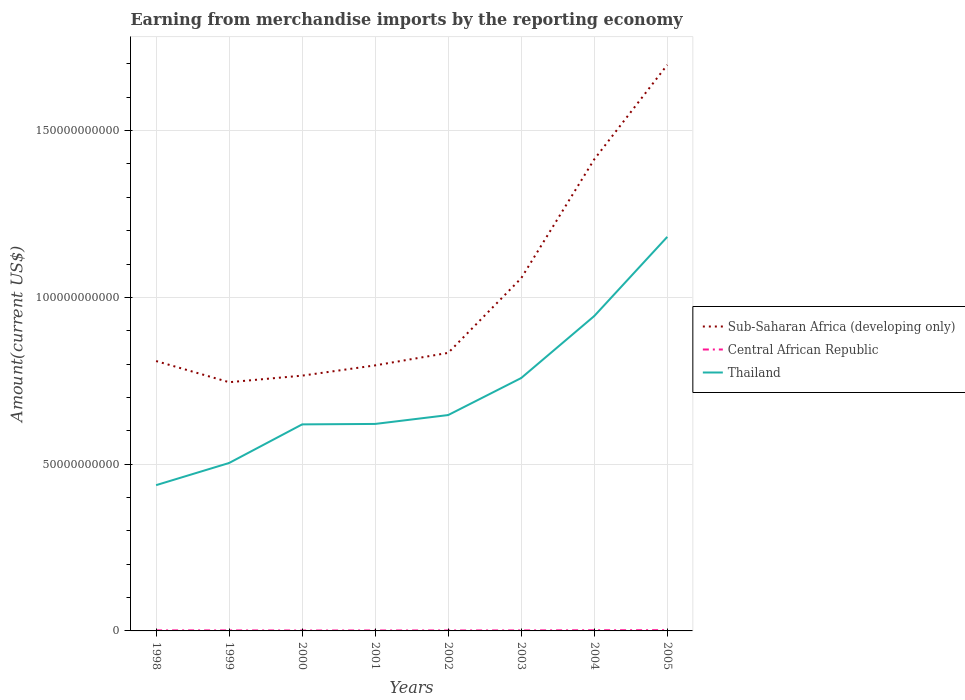How many different coloured lines are there?
Your answer should be very brief. 3. Does the line corresponding to Sub-Saharan Africa (developing only) intersect with the line corresponding to Central African Republic?
Provide a short and direct response. No. Is the number of lines equal to the number of legend labels?
Your answer should be very brief. Yes. Across all years, what is the maximum amount earned from merchandise imports in Sub-Saharan Africa (developing only)?
Your answer should be very brief. 7.46e+1. In which year was the amount earned from merchandise imports in Thailand maximum?
Your response must be concise. 1998. What is the total amount earned from merchandise imports in Central African Republic in the graph?
Make the answer very short. 7.74e+06. What is the difference between the highest and the second highest amount earned from merchandise imports in Thailand?
Your answer should be compact. 7.44e+1. What is the difference between the highest and the lowest amount earned from merchandise imports in Central African Republic?
Keep it short and to the point. 3. Is the amount earned from merchandise imports in Thailand strictly greater than the amount earned from merchandise imports in Central African Republic over the years?
Give a very brief answer. No. Where does the legend appear in the graph?
Give a very brief answer. Center right. How many legend labels are there?
Your response must be concise. 3. How are the legend labels stacked?
Offer a terse response. Vertical. What is the title of the graph?
Your response must be concise. Earning from merchandise imports by the reporting economy. Does "Zambia" appear as one of the legend labels in the graph?
Keep it short and to the point. No. What is the label or title of the X-axis?
Provide a short and direct response. Years. What is the label or title of the Y-axis?
Your answer should be very brief. Amount(current US$). What is the Amount(current US$) in Sub-Saharan Africa (developing only) in 1998?
Offer a terse response. 8.09e+1. What is the Amount(current US$) of Central African Republic in 1998?
Your answer should be very brief. 1.62e+08. What is the Amount(current US$) in Thailand in 1998?
Ensure brevity in your answer.  4.37e+1. What is the Amount(current US$) of Sub-Saharan Africa (developing only) in 1999?
Offer a terse response. 7.46e+1. What is the Amount(current US$) in Central African Republic in 1999?
Make the answer very short. 1.54e+08. What is the Amount(current US$) in Thailand in 1999?
Ensure brevity in your answer.  5.04e+1. What is the Amount(current US$) of Sub-Saharan Africa (developing only) in 2000?
Ensure brevity in your answer.  7.65e+1. What is the Amount(current US$) of Central African Republic in 2000?
Provide a short and direct response. 1.21e+08. What is the Amount(current US$) in Thailand in 2000?
Your answer should be very brief. 6.19e+1. What is the Amount(current US$) of Sub-Saharan Africa (developing only) in 2001?
Your answer should be compact. 7.96e+1. What is the Amount(current US$) in Central African Republic in 2001?
Provide a short and direct response. 1.34e+08. What is the Amount(current US$) in Thailand in 2001?
Offer a terse response. 6.21e+1. What is the Amount(current US$) in Sub-Saharan Africa (developing only) in 2002?
Make the answer very short. 8.34e+1. What is the Amount(current US$) in Central African Republic in 2002?
Offer a terse response. 1.41e+08. What is the Amount(current US$) in Thailand in 2002?
Provide a succinct answer. 6.47e+1. What is the Amount(current US$) of Sub-Saharan Africa (developing only) in 2003?
Offer a terse response. 1.06e+11. What is the Amount(current US$) of Central African Republic in 2003?
Offer a terse response. 1.48e+08. What is the Amount(current US$) in Thailand in 2003?
Ensure brevity in your answer.  7.58e+1. What is the Amount(current US$) in Sub-Saharan Africa (developing only) in 2004?
Provide a short and direct response. 1.41e+11. What is the Amount(current US$) in Central African Republic in 2004?
Give a very brief answer. 2.02e+08. What is the Amount(current US$) of Thailand in 2004?
Give a very brief answer. 9.44e+1. What is the Amount(current US$) in Sub-Saharan Africa (developing only) in 2005?
Your response must be concise. 1.70e+11. What is the Amount(current US$) of Central African Republic in 2005?
Keep it short and to the point. 2.25e+08. What is the Amount(current US$) in Thailand in 2005?
Your response must be concise. 1.18e+11. Across all years, what is the maximum Amount(current US$) of Sub-Saharan Africa (developing only)?
Make the answer very short. 1.70e+11. Across all years, what is the maximum Amount(current US$) in Central African Republic?
Provide a succinct answer. 2.25e+08. Across all years, what is the maximum Amount(current US$) of Thailand?
Offer a very short reply. 1.18e+11. Across all years, what is the minimum Amount(current US$) in Sub-Saharan Africa (developing only)?
Provide a succinct answer. 7.46e+1. Across all years, what is the minimum Amount(current US$) in Central African Republic?
Your answer should be compact. 1.21e+08. Across all years, what is the minimum Amount(current US$) of Thailand?
Give a very brief answer. 4.37e+1. What is the total Amount(current US$) in Sub-Saharan Africa (developing only) in the graph?
Offer a very short reply. 8.12e+11. What is the total Amount(current US$) in Central African Republic in the graph?
Your response must be concise. 1.29e+09. What is the total Amount(current US$) in Thailand in the graph?
Offer a terse response. 5.71e+11. What is the difference between the Amount(current US$) in Sub-Saharan Africa (developing only) in 1998 and that in 1999?
Give a very brief answer. 6.34e+09. What is the difference between the Amount(current US$) of Central African Republic in 1998 and that in 1999?
Provide a succinct answer. 7.74e+06. What is the difference between the Amount(current US$) in Thailand in 1998 and that in 1999?
Keep it short and to the point. -6.65e+09. What is the difference between the Amount(current US$) in Sub-Saharan Africa (developing only) in 1998 and that in 2000?
Your answer should be compact. 4.37e+09. What is the difference between the Amount(current US$) of Central African Republic in 1998 and that in 2000?
Provide a succinct answer. 4.08e+07. What is the difference between the Amount(current US$) of Thailand in 1998 and that in 2000?
Ensure brevity in your answer.  -1.82e+1. What is the difference between the Amount(current US$) in Sub-Saharan Africa (developing only) in 1998 and that in 2001?
Offer a very short reply. 1.30e+09. What is the difference between the Amount(current US$) of Central African Republic in 1998 and that in 2001?
Your answer should be compact. 2.71e+07. What is the difference between the Amount(current US$) of Thailand in 1998 and that in 2001?
Make the answer very short. -1.84e+1. What is the difference between the Amount(current US$) of Sub-Saharan Africa (developing only) in 1998 and that in 2002?
Make the answer very short. -2.45e+09. What is the difference between the Amount(current US$) in Central African Republic in 1998 and that in 2002?
Make the answer very short. 2.07e+07. What is the difference between the Amount(current US$) in Thailand in 1998 and that in 2002?
Ensure brevity in your answer.  -2.10e+1. What is the difference between the Amount(current US$) of Sub-Saharan Africa (developing only) in 1998 and that in 2003?
Provide a short and direct response. -2.48e+1. What is the difference between the Amount(current US$) in Central African Republic in 1998 and that in 2003?
Ensure brevity in your answer.  1.36e+07. What is the difference between the Amount(current US$) in Thailand in 1998 and that in 2003?
Offer a very short reply. -3.21e+1. What is the difference between the Amount(current US$) in Sub-Saharan Africa (developing only) in 1998 and that in 2004?
Give a very brief answer. -6.05e+1. What is the difference between the Amount(current US$) of Central African Republic in 1998 and that in 2004?
Give a very brief answer. -4.06e+07. What is the difference between the Amount(current US$) of Thailand in 1998 and that in 2004?
Your answer should be compact. -5.07e+1. What is the difference between the Amount(current US$) of Sub-Saharan Africa (developing only) in 1998 and that in 2005?
Offer a very short reply. -8.88e+1. What is the difference between the Amount(current US$) in Central African Republic in 1998 and that in 2005?
Offer a terse response. -6.38e+07. What is the difference between the Amount(current US$) in Thailand in 1998 and that in 2005?
Make the answer very short. -7.44e+1. What is the difference between the Amount(current US$) of Sub-Saharan Africa (developing only) in 1999 and that in 2000?
Your answer should be very brief. -1.97e+09. What is the difference between the Amount(current US$) of Central African Republic in 1999 and that in 2000?
Offer a very short reply. 3.31e+07. What is the difference between the Amount(current US$) of Thailand in 1999 and that in 2000?
Your response must be concise. -1.16e+1. What is the difference between the Amount(current US$) of Sub-Saharan Africa (developing only) in 1999 and that in 2001?
Make the answer very short. -5.05e+09. What is the difference between the Amount(current US$) in Central African Republic in 1999 and that in 2001?
Keep it short and to the point. 1.94e+07. What is the difference between the Amount(current US$) of Thailand in 1999 and that in 2001?
Offer a terse response. -1.17e+1. What is the difference between the Amount(current US$) of Sub-Saharan Africa (developing only) in 1999 and that in 2002?
Provide a short and direct response. -8.80e+09. What is the difference between the Amount(current US$) in Central African Republic in 1999 and that in 2002?
Provide a short and direct response. 1.29e+07. What is the difference between the Amount(current US$) in Thailand in 1999 and that in 2002?
Your answer should be very brief. -1.44e+1. What is the difference between the Amount(current US$) in Sub-Saharan Africa (developing only) in 1999 and that in 2003?
Provide a succinct answer. -3.12e+1. What is the difference between the Amount(current US$) of Central African Republic in 1999 and that in 2003?
Your response must be concise. 5.91e+06. What is the difference between the Amount(current US$) in Thailand in 1999 and that in 2003?
Offer a very short reply. -2.55e+1. What is the difference between the Amount(current US$) of Sub-Saharan Africa (developing only) in 1999 and that in 2004?
Ensure brevity in your answer.  -6.68e+1. What is the difference between the Amount(current US$) in Central African Republic in 1999 and that in 2004?
Your answer should be very brief. -4.83e+07. What is the difference between the Amount(current US$) of Thailand in 1999 and that in 2004?
Ensure brevity in your answer.  -4.41e+1. What is the difference between the Amount(current US$) of Sub-Saharan Africa (developing only) in 1999 and that in 2005?
Your response must be concise. -9.51e+1. What is the difference between the Amount(current US$) of Central African Republic in 1999 and that in 2005?
Offer a terse response. -7.16e+07. What is the difference between the Amount(current US$) of Thailand in 1999 and that in 2005?
Give a very brief answer. -6.78e+1. What is the difference between the Amount(current US$) in Sub-Saharan Africa (developing only) in 2000 and that in 2001?
Your answer should be compact. -3.07e+09. What is the difference between the Amount(current US$) of Central African Republic in 2000 and that in 2001?
Give a very brief answer. -1.37e+07. What is the difference between the Amount(current US$) in Thailand in 2000 and that in 2001?
Offer a very short reply. -1.34e+08. What is the difference between the Amount(current US$) of Sub-Saharan Africa (developing only) in 2000 and that in 2002?
Your answer should be compact. -6.83e+09. What is the difference between the Amount(current US$) in Central African Republic in 2000 and that in 2002?
Keep it short and to the point. -2.02e+07. What is the difference between the Amount(current US$) in Thailand in 2000 and that in 2002?
Ensure brevity in your answer.  -2.80e+09. What is the difference between the Amount(current US$) of Sub-Saharan Africa (developing only) in 2000 and that in 2003?
Provide a succinct answer. -2.92e+1. What is the difference between the Amount(current US$) of Central African Republic in 2000 and that in 2003?
Provide a short and direct response. -2.72e+07. What is the difference between the Amount(current US$) in Thailand in 2000 and that in 2003?
Your answer should be very brief. -1.39e+1. What is the difference between the Amount(current US$) in Sub-Saharan Africa (developing only) in 2000 and that in 2004?
Your answer should be compact. -6.49e+1. What is the difference between the Amount(current US$) in Central African Republic in 2000 and that in 2004?
Ensure brevity in your answer.  -8.14e+07. What is the difference between the Amount(current US$) of Thailand in 2000 and that in 2004?
Provide a succinct answer. -3.25e+1. What is the difference between the Amount(current US$) in Sub-Saharan Africa (developing only) in 2000 and that in 2005?
Your answer should be compact. -9.32e+1. What is the difference between the Amount(current US$) of Central African Republic in 2000 and that in 2005?
Make the answer very short. -1.05e+08. What is the difference between the Amount(current US$) in Thailand in 2000 and that in 2005?
Your response must be concise. -5.62e+1. What is the difference between the Amount(current US$) of Sub-Saharan Africa (developing only) in 2001 and that in 2002?
Offer a very short reply. -3.75e+09. What is the difference between the Amount(current US$) in Central African Republic in 2001 and that in 2002?
Offer a very short reply. -6.45e+06. What is the difference between the Amount(current US$) in Thailand in 2001 and that in 2002?
Provide a succinct answer. -2.66e+09. What is the difference between the Amount(current US$) in Sub-Saharan Africa (developing only) in 2001 and that in 2003?
Offer a very short reply. -2.61e+1. What is the difference between the Amount(current US$) of Central African Republic in 2001 and that in 2003?
Your answer should be very brief. -1.35e+07. What is the difference between the Amount(current US$) of Thailand in 2001 and that in 2003?
Your answer should be very brief. -1.38e+1. What is the difference between the Amount(current US$) of Sub-Saharan Africa (developing only) in 2001 and that in 2004?
Ensure brevity in your answer.  -6.18e+1. What is the difference between the Amount(current US$) in Central African Republic in 2001 and that in 2004?
Your answer should be very brief. -6.77e+07. What is the difference between the Amount(current US$) in Thailand in 2001 and that in 2004?
Your answer should be compact. -3.24e+1. What is the difference between the Amount(current US$) of Sub-Saharan Africa (developing only) in 2001 and that in 2005?
Give a very brief answer. -9.01e+1. What is the difference between the Amount(current US$) of Central African Republic in 2001 and that in 2005?
Give a very brief answer. -9.09e+07. What is the difference between the Amount(current US$) of Thailand in 2001 and that in 2005?
Provide a succinct answer. -5.61e+1. What is the difference between the Amount(current US$) in Sub-Saharan Africa (developing only) in 2002 and that in 2003?
Give a very brief answer. -2.24e+1. What is the difference between the Amount(current US$) in Central African Republic in 2002 and that in 2003?
Keep it short and to the point. -7.00e+06. What is the difference between the Amount(current US$) of Thailand in 2002 and that in 2003?
Make the answer very short. -1.11e+1. What is the difference between the Amount(current US$) in Sub-Saharan Africa (developing only) in 2002 and that in 2004?
Offer a terse response. -5.80e+1. What is the difference between the Amount(current US$) of Central African Republic in 2002 and that in 2004?
Your answer should be very brief. -6.13e+07. What is the difference between the Amount(current US$) of Thailand in 2002 and that in 2004?
Your answer should be compact. -2.97e+1. What is the difference between the Amount(current US$) in Sub-Saharan Africa (developing only) in 2002 and that in 2005?
Keep it short and to the point. -8.63e+1. What is the difference between the Amount(current US$) in Central African Republic in 2002 and that in 2005?
Your answer should be very brief. -8.45e+07. What is the difference between the Amount(current US$) of Thailand in 2002 and that in 2005?
Provide a succinct answer. -5.34e+1. What is the difference between the Amount(current US$) in Sub-Saharan Africa (developing only) in 2003 and that in 2004?
Your response must be concise. -3.56e+1. What is the difference between the Amount(current US$) in Central African Republic in 2003 and that in 2004?
Provide a short and direct response. -5.42e+07. What is the difference between the Amount(current US$) in Thailand in 2003 and that in 2004?
Offer a very short reply. -1.86e+1. What is the difference between the Amount(current US$) of Sub-Saharan Africa (developing only) in 2003 and that in 2005?
Offer a terse response. -6.40e+1. What is the difference between the Amount(current US$) in Central African Republic in 2003 and that in 2005?
Your response must be concise. -7.75e+07. What is the difference between the Amount(current US$) in Thailand in 2003 and that in 2005?
Your answer should be compact. -4.23e+1. What is the difference between the Amount(current US$) of Sub-Saharan Africa (developing only) in 2004 and that in 2005?
Your response must be concise. -2.83e+1. What is the difference between the Amount(current US$) of Central African Republic in 2004 and that in 2005?
Offer a terse response. -2.32e+07. What is the difference between the Amount(current US$) in Thailand in 2004 and that in 2005?
Provide a short and direct response. -2.37e+1. What is the difference between the Amount(current US$) in Sub-Saharan Africa (developing only) in 1998 and the Amount(current US$) in Central African Republic in 1999?
Your response must be concise. 8.08e+1. What is the difference between the Amount(current US$) in Sub-Saharan Africa (developing only) in 1998 and the Amount(current US$) in Thailand in 1999?
Make the answer very short. 3.06e+1. What is the difference between the Amount(current US$) in Central African Republic in 1998 and the Amount(current US$) in Thailand in 1999?
Provide a short and direct response. -5.02e+1. What is the difference between the Amount(current US$) in Sub-Saharan Africa (developing only) in 1998 and the Amount(current US$) in Central African Republic in 2000?
Provide a succinct answer. 8.08e+1. What is the difference between the Amount(current US$) in Sub-Saharan Africa (developing only) in 1998 and the Amount(current US$) in Thailand in 2000?
Provide a short and direct response. 1.90e+1. What is the difference between the Amount(current US$) of Central African Republic in 1998 and the Amount(current US$) of Thailand in 2000?
Provide a succinct answer. -6.18e+1. What is the difference between the Amount(current US$) in Sub-Saharan Africa (developing only) in 1998 and the Amount(current US$) in Central African Republic in 2001?
Provide a succinct answer. 8.08e+1. What is the difference between the Amount(current US$) of Sub-Saharan Africa (developing only) in 1998 and the Amount(current US$) of Thailand in 2001?
Give a very brief answer. 1.89e+1. What is the difference between the Amount(current US$) of Central African Republic in 1998 and the Amount(current US$) of Thailand in 2001?
Keep it short and to the point. -6.19e+1. What is the difference between the Amount(current US$) of Sub-Saharan Africa (developing only) in 1998 and the Amount(current US$) of Central African Republic in 2002?
Provide a succinct answer. 8.08e+1. What is the difference between the Amount(current US$) in Sub-Saharan Africa (developing only) in 1998 and the Amount(current US$) in Thailand in 2002?
Your response must be concise. 1.62e+1. What is the difference between the Amount(current US$) of Central African Republic in 1998 and the Amount(current US$) of Thailand in 2002?
Provide a succinct answer. -6.46e+1. What is the difference between the Amount(current US$) in Sub-Saharan Africa (developing only) in 1998 and the Amount(current US$) in Central African Republic in 2003?
Ensure brevity in your answer.  8.08e+1. What is the difference between the Amount(current US$) of Sub-Saharan Africa (developing only) in 1998 and the Amount(current US$) of Thailand in 2003?
Your answer should be very brief. 5.09e+09. What is the difference between the Amount(current US$) of Central African Republic in 1998 and the Amount(current US$) of Thailand in 2003?
Your answer should be compact. -7.57e+1. What is the difference between the Amount(current US$) in Sub-Saharan Africa (developing only) in 1998 and the Amount(current US$) in Central African Republic in 2004?
Your answer should be compact. 8.07e+1. What is the difference between the Amount(current US$) of Sub-Saharan Africa (developing only) in 1998 and the Amount(current US$) of Thailand in 2004?
Provide a succinct answer. -1.35e+1. What is the difference between the Amount(current US$) of Central African Republic in 1998 and the Amount(current US$) of Thailand in 2004?
Offer a very short reply. -9.42e+1. What is the difference between the Amount(current US$) of Sub-Saharan Africa (developing only) in 1998 and the Amount(current US$) of Central African Republic in 2005?
Offer a very short reply. 8.07e+1. What is the difference between the Amount(current US$) in Sub-Saharan Africa (developing only) in 1998 and the Amount(current US$) in Thailand in 2005?
Make the answer very short. -3.72e+1. What is the difference between the Amount(current US$) in Central African Republic in 1998 and the Amount(current US$) in Thailand in 2005?
Keep it short and to the point. -1.18e+11. What is the difference between the Amount(current US$) in Sub-Saharan Africa (developing only) in 1999 and the Amount(current US$) in Central African Republic in 2000?
Offer a very short reply. 7.44e+1. What is the difference between the Amount(current US$) of Sub-Saharan Africa (developing only) in 1999 and the Amount(current US$) of Thailand in 2000?
Your answer should be very brief. 1.26e+1. What is the difference between the Amount(current US$) in Central African Republic in 1999 and the Amount(current US$) in Thailand in 2000?
Give a very brief answer. -6.18e+1. What is the difference between the Amount(current US$) of Sub-Saharan Africa (developing only) in 1999 and the Amount(current US$) of Central African Republic in 2001?
Your answer should be compact. 7.44e+1. What is the difference between the Amount(current US$) of Sub-Saharan Africa (developing only) in 1999 and the Amount(current US$) of Thailand in 2001?
Offer a very short reply. 1.25e+1. What is the difference between the Amount(current US$) in Central African Republic in 1999 and the Amount(current US$) in Thailand in 2001?
Keep it short and to the point. -6.19e+1. What is the difference between the Amount(current US$) of Sub-Saharan Africa (developing only) in 1999 and the Amount(current US$) of Central African Republic in 2002?
Your response must be concise. 7.44e+1. What is the difference between the Amount(current US$) of Sub-Saharan Africa (developing only) in 1999 and the Amount(current US$) of Thailand in 2002?
Give a very brief answer. 9.85e+09. What is the difference between the Amount(current US$) in Central African Republic in 1999 and the Amount(current US$) in Thailand in 2002?
Offer a very short reply. -6.46e+1. What is the difference between the Amount(current US$) in Sub-Saharan Africa (developing only) in 1999 and the Amount(current US$) in Central African Republic in 2003?
Offer a very short reply. 7.44e+1. What is the difference between the Amount(current US$) in Sub-Saharan Africa (developing only) in 1999 and the Amount(current US$) in Thailand in 2003?
Offer a very short reply. -1.26e+09. What is the difference between the Amount(current US$) in Central African Republic in 1999 and the Amount(current US$) in Thailand in 2003?
Offer a very short reply. -7.57e+1. What is the difference between the Amount(current US$) in Sub-Saharan Africa (developing only) in 1999 and the Amount(current US$) in Central African Republic in 2004?
Your answer should be very brief. 7.44e+1. What is the difference between the Amount(current US$) in Sub-Saharan Africa (developing only) in 1999 and the Amount(current US$) in Thailand in 2004?
Keep it short and to the point. -1.98e+1. What is the difference between the Amount(current US$) of Central African Republic in 1999 and the Amount(current US$) of Thailand in 2004?
Make the answer very short. -9.43e+1. What is the difference between the Amount(current US$) of Sub-Saharan Africa (developing only) in 1999 and the Amount(current US$) of Central African Republic in 2005?
Your answer should be compact. 7.43e+1. What is the difference between the Amount(current US$) in Sub-Saharan Africa (developing only) in 1999 and the Amount(current US$) in Thailand in 2005?
Offer a very short reply. -4.36e+1. What is the difference between the Amount(current US$) of Central African Republic in 1999 and the Amount(current US$) of Thailand in 2005?
Offer a terse response. -1.18e+11. What is the difference between the Amount(current US$) in Sub-Saharan Africa (developing only) in 2000 and the Amount(current US$) in Central African Republic in 2001?
Your response must be concise. 7.64e+1. What is the difference between the Amount(current US$) of Sub-Saharan Africa (developing only) in 2000 and the Amount(current US$) of Thailand in 2001?
Make the answer very short. 1.45e+1. What is the difference between the Amount(current US$) of Central African Republic in 2000 and the Amount(current US$) of Thailand in 2001?
Offer a terse response. -6.19e+1. What is the difference between the Amount(current US$) in Sub-Saharan Africa (developing only) in 2000 and the Amount(current US$) in Central African Republic in 2002?
Provide a short and direct response. 7.64e+1. What is the difference between the Amount(current US$) of Sub-Saharan Africa (developing only) in 2000 and the Amount(current US$) of Thailand in 2002?
Offer a very short reply. 1.18e+1. What is the difference between the Amount(current US$) in Central African Republic in 2000 and the Amount(current US$) in Thailand in 2002?
Make the answer very short. -6.46e+1. What is the difference between the Amount(current US$) of Sub-Saharan Africa (developing only) in 2000 and the Amount(current US$) of Central African Republic in 2003?
Provide a succinct answer. 7.64e+1. What is the difference between the Amount(current US$) in Sub-Saharan Africa (developing only) in 2000 and the Amount(current US$) in Thailand in 2003?
Provide a short and direct response. 7.14e+08. What is the difference between the Amount(current US$) of Central African Republic in 2000 and the Amount(current US$) of Thailand in 2003?
Your answer should be very brief. -7.57e+1. What is the difference between the Amount(current US$) of Sub-Saharan Africa (developing only) in 2000 and the Amount(current US$) of Central African Republic in 2004?
Ensure brevity in your answer.  7.63e+1. What is the difference between the Amount(current US$) in Sub-Saharan Africa (developing only) in 2000 and the Amount(current US$) in Thailand in 2004?
Provide a short and direct response. -1.79e+1. What is the difference between the Amount(current US$) of Central African Republic in 2000 and the Amount(current US$) of Thailand in 2004?
Offer a terse response. -9.43e+1. What is the difference between the Amount(current US$) in Sub-Saharan Africa (developing only) in 2000 and the Amount(current US$) in Central African Republic in 2005?
Offer a terse response. 7.63e+1. What is the difference between the Amount(current US$) of Sub-Saharan Africa (developing only) in 2000 and the Amount(current US$) of Thailand in 2005?
Your answer should be very brief. -4.16e+1. What is the difference between the Amount(current US$) in Central African Republic in 2000 and the Amount(current US$) in Thailand in 2005?
Ensure brevity in your answer.  -1.18e+11. What is the difference between the Amount(current US$) of Sub-Saharan Africa (developing only) in 2001 and the Amount(current US$) of Central African Republic in 2002?
Provide a succinct answer. 7.95e+1. What is the difference between the Amount(current US$) of Sub-Saharan Africa (developing only) in 2001 and the Amount(current US$) of Thailand in 2002?
Keep it short and to the point. 1.49e+1. What is the difference between the Amount(current US$) in Central African Republic in 2001 and the Amount(current US$) in Thailand in 2002?
Your answer should be compact. -6.46e+1. What is the difference between the Amount(current US$) of Sub-Saharan Africa (developing only) in 2001 and the Amount(current US$) of Central African Republic in 2003?
Provide a short and direct response. 7.95e+1. What is the difference between the Amount(current US$) in Sub-Saharan Africa (developing only) in 2001 and the Amount(current US$) in Thailand in 2003?
Make the answer very short. 3.79e+09. What is the difference between the Amount(current US$) in Central African Republic in 2001 and the Amount(current US$) in Thailand in 2003?
Give a very brief answer. -7.57e+1. What is the difference between the Amount(current US$) in Sub-Saharan Africa (developing only) in 2001 and the Amount(current US$) in Central African Republic in 2004?
Your response must be concise. 7.94e+1. What is the difference between the Amount(current US$) in Sub-Saharan Africa (developing only) in 2001 and the Amount(current US$) in Thailand in 2004?
Keep it short and to the point. -1.48e+1. What is the difference between the Amount(current US$) of Central African Republic in 2001 and the Amount(current US$) of Thailand in 2004?
Your answer should be compact. -9.43e+1. What is the difference between the Amount(current US$) of Sub-Saharan Africa (developing only) in 2001 and the Amount(current US$) of Central African Republic in 2005?
Make the answer very short. 7.94e+1. What is the difference between the Amount(current US$) in Sub-Saharan Africa (developing only) in 2001 and the Amount(current US$) in Thailand in 2005?
Give a very brief answer. -3.85e+1. What is the difference between the Amount(current US$) of Central African Republic in 2001 and the Amount(current US$) of Thailand in 2005?
Ensure brevity in your answer.  -1.18e+11. What is the difference between the Amount(current US$) in Sub-Saharan Africa (developing only) in 2002 and the Amount(current US$) in Central African Republic in 2003?
Ensure brevity in your answer.  8.32e+1. What is the difference between the Amount(current US$) in Sub-Saharan Africa (developing only) in 2002 and the Amount(current US$) in Thailand in 2003?
Your answer should be very brief. 7.54e+09. What is the difference between the Amount(current US$) of Central African Republic in 2002 and the Amount(current US$) of Thailand in 2003?
Ensure brevity in your answer.  -7.57e+1. What is the difference between the Amount(current US$) in Sub-Saharan Africa (developing only) in 2002 and the Amount(current US$) in Central African Republic in 2004?
Keep it short and to the point. 8.32e+1. What is the difference between the Amount(current US$) of Sub-Saharan Africa (developing only) in 2002 and the Amount(current US$) of Thailand in 2004?
Ensure brevity in your answer.  -1.10e+1. What is the difference between the Amount(current US$) of Central African Republic in 2002 and the Amount(current US$) of Thailand in 2004?
Your answer should be very brief. -9.43e+1. What is the difference between the Amount(current US$) of Sub-Saharan Africa (developing only) in 2002 and the Amount(current US$) of Central African Republic in 2005?
Ensure brevity in your answer.  8.31e+1. What is the difference between the Amount(current US$) in Sub-Saharan Africa (developing only) in 2002 and the Amount(current US$) in Thailand in 2005?
Ensure brevity in your answer.  -3.48e+1. What is the difference between the Amount(current US$) in Central African Republic in 2002 and the Amount(current US$) in Thailand in 2005?
Your answer should be very brief. -1.18e+11. What is the difference between the Amount(current US$) in Sub-Saharan Africa (developing only) in 2003 and the Amount(current US$) in Central African Republic in 2004?
Your response must be concise. 1.06e+11. What is the difference between the Amount(current US$) of Sub-Saharan Africa (developing only) in 2003 and the Amount(current US$) of Thailand in 2004?
Ensure brevity in your answer.  1.14e+1. What is the difference between the Amount(current US$) of Central African Republic in 2003 and the Amount(current US$) of Thailand in 2004?
Ensure brevity in your answer.  -9.43e+1. What is the difference between the Amount(current US$) in Sub-Saharan Africa (developing only) in 2003 and the Amount(current US$) in Central African Republic in 2005?
Make the answer very short. 1.06e+11. What is the difference between the Amount(current US$) of Sub-Saharan Africa (developing only) in 2003 and the Amount(current US$) of Thailand in 2005?
Make the answer very short. -1.24e+1. What is the difference between the Amount(current US$) of Central African Republic in 2003 and the Amount(current US$) of Thailand in 2005?
Keep it short and to the point. -1.18e+11. What is the difference between the Amount(current US$) of Sub-Saharan Africa (developing only) in 2004 and the Amount(current US$) of Central African Republic in 2005?
Your answer should be compact. 1.41e+11. What is the difference between the Amount(current US$) of Sub-Saharan Africa (developing only) in 2004 and the Amount(current US$) of Thailand in 2005?
Your answer should be compact. 2.32e+1. What is the difference between the Amount(current US$) in Central African Republic in 2004 and the Amount(current US$) in Thailand in 2005?
Offer a very short reply. -1.18e+11. What is the average Amount(current US$) in Sub-Saharan Africa (developing only) per year?
Offer a terse response. 1.01e+11. What is the average Amount(current US$) of Central African Republic per year?
Your answer should be very brief. 1.61e+08. What is the average Amount(current US$) of Thailand per year?
Your response must be concise. 7.14e+1. In the year 1998, what is the difference between the Amount(current US$) in Sub-Saharan Africa (developing only) and Amount(current US$) in Central African Republic?
Offer a terse response. 8.07e+1. In the year 1998, what is the difference between the Amount(current US$) of Sub-Saharan Africa (developing only) and Amount(current US$) of Thailand?
Provide a short and direct response. 3.72e+1. In the year 1998, what is the difference between the Amount(current US$) of Central African Republic and Amount(current US$) of Thailand?
Provide a succinct answer. -4.35e+1. In the year 1999, what is the difference between the Amount(current US$) in Sub-Saharan Africa (developing only) and Amount(current US$) in Central African Republic?
Your answer should be very brief. 7.44e+1. In the year 1999, what is the difference between the Amount(current US$) of Sub-Saharan Africa (developing only) and Amount(current US$) of Thailand?
Make the answer very short. 2.42e+1. In the year 1999, what is the difference between the Amount(current US$) of Central African Republic and Amount(current US$) of Thailand?
Your response must be concise. -5.02e+1. In the year 2000, what is the difference between the Amount(current US$) of Sub-Saharan Africa (developing only) and Amount(current US$) of Central African Republic?
Keep it short and to the point. 7.64e+1. In the year 2000, what is the difference between the Amount(current US$) of Sub-Saharan Africa (developing only) and Amount(current US$) of Thailand?
Offer a very short reply. 1.46e+1. In the year 2000, what is the difference between the Amount(current US$) in Central African Republic and Amount(current US$) in Thailand?
Your response must be concise. -6.18e+1. In the year 2001, what is the difference between the Amount(current US$) of Sub-Saharan Africa (developing only) and Amount(current US$) of Central African Republic?
Provide a short and direct response. 7.95e+1. In the year 2001, what is the difference between the Amount(current US$) of Sub-Saharan Africa (developing only) and Amount(current US$) of Thailand?
Your answer should be very brief. 1.76e+1. In the year 2001, what is the difference between the Amount(current US$) of Central African Republic and Amount(current US$) of Thailand?
Provide a short and direct response. -6.19e+1. In the year 2002, what is the difference between the Amount(current US$) of Sub-Saharan Africa (developing only) and Amount(current US$) of Central African Republic?
Offer a terse response. 8.32e+1. In the year 2002, what is the difference between the Amount(current US$) of Sub-Saharan Africa (developing only) and Amount(current US$) of Thailand?
Your response must be concise. 1.86e+1. In the year 2002, what is the difference between the Amount(current US$) in Central African Republic and Amount(current US$) in Thailand?
Provide a short and direct response. -6.46e+1. In the year 2003, what is the difference between the Amount(current US$) in Sub-Saharan Africa (developing only) and Amount(current US$) in Central African Republic?
Your answer should be compact. 1.06e+11. In the year 2003, what is the difference between the Amount(current US$) in Sub-Saharan Africa (developing only) and Amount(current US$) in Thailand?
Provide a short and direct response. 2.99e+1. In the year 2003, what is the difference between the Amount(current US$) of Central African Republic and Amount(current US$) of Thailand?
Give a very brief answer. -7.57e+1. In the year 2004, what is the difference between the Amount(current US$) in Sub-Saharan Africa (developing only) and Amount(current US$) in Central African Republic?
Ensure brevity in your answer.  1.41e+11. In the year 2004, what is the difference between the Amount(current US$) in Sub-Saharan Africa (developing only) and Amount(current US$) in Thailand?
Offer a very short reply. 4.70e+1. In the year 2004, what is the difference between the Amount(current US$) in Central African Republic and Amount(current US$) in Thailand?
Give a very brief answer. -9.42e+1. In the year 2005, what is the difference between the Amount(current US$) of Sub-Saharan Africa (developing only) and Amount(current US$) of Central African Republic?
Your response must be concise. 1.69e+11. In the year 2005, what is the difference between the Amount(current US$) of Sub-Saharan Africa (developing only) and Amount(current US$) of Thailand?
Give a very brief answer. 5.16e+1. In the year 2005, what is the difference between the Amount(current US$) of Central African Republic and Amount(current US$) of Thailand?
Your response must be concise. -1.18e+11. What is the ratio of the Amount(current US$) in Sub-Saharan Africa (developing only) in 1998 to that in 1999?
Offer a terse response. 1.09. What is the ratio of the Amount(current US$) in Central African Republic in 1998 to that in 1999?
Your answer should be compact. 1.05. What is the ratio of the Amount(current US$) in Thailand in 1998 to that in 1999?
Offer a very short reply. 0.87. What is the ratio of the Amount(current US$) in Sub-Saharan Africa (developing only) in 1998 to that in 2000?
Your response must be concise. 1.06. What is the ratio of the Amount(current US$) of Central African Republic in 1998 to that in 2000?
Your response must be concise. 1.34. What is the ratio of the Amount(current US$) in Thailand in 1998 to that in 2000?
Provide a short and direct response. 0.71. What is the ratio of the Amount(current US$) in Sub-Saharan Africa (developing only) in 1998 to that in 2001?
Provide a succinct answer. 1.02. What is the ratio of the Amount(current US$) of Central African Republic in 1998 to that in 2001?
Make the answer very short. 1.2. What is the ratio of the Amount(current US$) of Thailand in 1998 to that in 2001?
Provide a short and direct response. 0.7. What is the ratio of the Amount(current US$) of Sub-Saharan Africa (developing only) in 1998 to that in 2002?
Make the answer very short. 0.97. What is the ratio of the Amount(current US$) of Central African Republic in 1998 to that in 2002?
Provide a short and direct response. 1.15. What is the ratio of the Amount(current US$) of Thailand in 1998 to that in 2002?
Your answer should be compact. 0.68. What is the ratio of the Amount(current US$) in Sub-Saharan Africa (developing only) in 1998 to that in 2003?
Provide a succinct answer. 0.77. What is the ratio of the Amount(current US$) in Central African Republic in 1998 to that in 2003?
Make the answer very short. 1.09. What is the ratio of the Amount(current US$) of Thailand in 1998 to that in 2003?
Your response must be concise. 0.58. What is the ratio of the Amount(current US$) of Sub-Saharan Africa (developing only) in 1998 to that in 2004?
Make the answer very short. 0.57. What is the ratio of the Amount(current US$) in Central African Republic in 1998 to that in 2004?
Offer a terse response. 0.8. What is the ratio of the Amount(current US$) in Thailand in 1998 to that in 2004?
Keep it short and to the point. 0.46. What is the ratio of the Amount(current US$) in Sub-Saharan Africa (developing only) in 1998 to that in 2005?
Ensure brevity in your answer.  0.48. What is the ratio of the Amount(current US$) of Central African Republic in 1998 to that in 2005?
Offer a terse response. 0.72. What is the ratio of the Amount(current US$) of Thailand in 1998 to that in 2005?
Offer a terse response. 0.37. What is the ratio of the Amount(current US$) of Sub-Saharan Africa (developing only) in 1999 to that in 2000?
Your answer should be compact. 0.97. What is the ratio of the Amount(current US$) in Central African Republic in 1999 to that in 2000?
Make the answer very short. 1.27. What is the ratio of the Amount(current US$) in Thailand in 1999 to that in 2000?
Make the answer very short. 0.81. What is the ratio of the Amount(current US$) in Sub-Saharan Africa (developing only) in 1999 to that in 2001?
Offer a terse response. 0.94. What is the ratio of the Amount(current US$) in Central African Republic in 1999 to that in 2001?
Provide a short and direct response. 1.14. What is the ratio of the Amount(current US$) in Thailand in 1999 to that in 2001?
Provide a short and direct response. 0.81. What is the ratio of the Amount(current US$) of Sub-Saharan Africa (developing only) in 1999 to that in 2002?
Provide a short and direct response. 0.89. What is the ratio of the Amount(current US$) in Central African Republic in 1999 to that in 2002?
Offer a terse response. 1.09. What is the ratio of the Amount(current US$) of Thailand in 1999 to that in 2002?
Provide a succinct answer. 0.78. What is the ratio of the Amount(current US$) in Sub-Saharan Africa (developing only) in 1999 to that in 2003?
Give a very brief answer. 0.71. What is the ratio of the Amount(current US$) of Thailand in 1999 to that in 2003?
Provide a short and direct response. 0.66. What is the ratio of the Amount(current US$) of Sub-Saharan Africa (developing only) in 1999 to that in 2004?
Provide a short and direct response. 0.53. What is the ratio of the Amount(current US$) in Central African Republic in 1999 to that in 2004?
Your answer should be very brief. 0.76. What is the ratio of the Amount(current US$) in Thailand in 1999 to that in 2004?
Ensure brevity in your answer.  0.53. What is the ratio of the Amount(current US$) of Sub-Saharan Africa (developing only) in 1999 to that in 2005?
Provide a succinct answer. 0.44. What is the ratio of the Amount(current US$) of Central African Republic in 1999 to that in 2005?
Keep it short and to the point. 0.68. What is the ratio of the Amount(current US$) in Thailand in 1999 to that in 2005?
Give a very brief answer. 0.43. What is the ratio of the Amount(current US$) of Sub-Saharan Africa (developing only) in 2000 to that in 2001?
Your answer should be very brief. 0.96. What is the ratio of the Amount(current US$) in Central African Republic in 2000 to that in 2001?
Your response must be concise. 0.9. What is the ratio of the Amount(current US$) in Thailand in 2000 to that in 2001?
Make the answer very short. 1. What is the ratio of the Amount(current US$) in Sub-Saharan Africa (developing only) in 2000 to that in 2002?
Keep it short and to the point. 0.92. What is the ratio of the Amount(current US$) of Central African Republic in 2000 to that in 2002?
Make the answer very short. 0.86. What is the ratio of the Amount(current US$) in Thailand in 2000 to that in 2002?
Make the answer very short. 0.96. What is the ratio of the Amount(current US$) in Sub-Saharan Africa (developing only) in 2000 to that in 2003?
Provide a succinct answer. 0.72. What is the ratio of the Amount(current US$) in Central African Republic in 2000 to that in 2003?
Your answer should be compact. 0.82. What is the ratio of the Amount(current US$) of Thailand in 2000 to that in 2003?
Make the answer very short. 0.82. What is the ratio of the Amount(current US$) in Sub-Saharan Africa (developing only) in 2000 to that in 2004?
Offer a terse response. 0.54. What is the ratio of the Amount(current US$) in Central African Republic in 2000 to that in 2004?
Ensure brevity in your answer.  0.6. What is the ratio of the Amount(current US$) of Thailand in 2000 to that in 2004?
Your answer should be compact. 0.66. What is the ratio of the Amount(current US$) in Sub-Saharan Africa (developing only) in 2000 to that in 2005?
Provide a short and direct response. 0.45. What is the ratio of the Amount(current US$) in Central African Republic in 2000 to that in 2005?
Your answer should be very brief. 0.54. What is the ratio of the Amount(current US$) in Thailand in 2000 to that in 2005?
Ensure brevity in your answer.  0.52. What is the ratio of the Amount(current US$) of Sub-Saharan Africa (developing only) in 2001 to that in 2002?
Keep it short and to the point. 0.95. What is the ratio of the Amount(current US$) in Central African Republic in 2001 to that in 2002?
Your response must be concise. 0.95. What is the ratio of the Amount(current US$) of Thailand in 2001 to that in 2002?
Provide a succinct answer. 0.96. What is the ratio of the Amount(current US$) of Sub-Saharan Africa (developing only) in 2001 to that in 2003?
Your answer should be compact. 0.75. What is the ratio of the Amount(current US$) of Central African Republic in 2001 to that in 2003?
Your response must be concise. 0.91. What is the ratio of the Amount(current US$) of Thailand in 2001 to that in 2003?
Your answer should be compact. 0.82. What is the ratio of the Amount(current US$) in Sub-Saharan Africa (developing only) in 2001 to that in 2004?
Your answer should be compact. 0.56. What is the ratio of the Amount(current US$) in Central African Republic in 2001 to that in 2004?
Give a very brief answer. 0.67. What is the ratio of the Amount(current US$) of Thailand in 2001 to that in 2004?
Your response must be concise. 0.66. What is the ratio of the Amount(current US$) of Sub-Saharan Africa (developing only) in 2001 to that in 2005?
Make the answer very short. 0.47. What is the ratio of the Amount(current US$) in Central African Republic in 2001 to that in 2005?
Make the answer very short. 0.6. What is the ratio of the Amount(current US$) in Thailand in 2001 to that in 2005?
Offer a very short reply. 0.53. What is the ratio of the Amount(current US$) in Sub-Saharan Africa (developing only) in 2002 to that in 2003?
Offer a terse response. 0.79. What is the ratio of the Amount(current US$) of Central African Republic in 2002 to that in 2003?
Give a very brief answer. 0.95. What is the ratio of the Amount(current US$) in Thailand in 2002 to that in 2003?
Offer a terse response. 0.85. What is the ratio of the Amount(current US$) in Sub-Saharan Africa (developing only) in 2002 to that in 2004?
Keep it short and to the point. 0.59. What is the ratio of the Amount(current US$) of Central African Republic in 2002 to that in 2004?
Your response must be concise. 0.7. What is the ratio of the Amount(current US$) in Thailand in 2002 to that in 2004?
Your answer should be compact. 0.69. What is the ratio of the Amount(current US$) in Sub-Saharan Africa (developing only) in 2002 to that in 2005?
Your answer should be compact. 0.49. What is the ratio of the Amount(current US$) of Central African Republic in 2002 to that in 2005?
Offer a very short reply. 0.63. What is the ratio of the Amount(current US$) of Thailand in 2002 to that in 2005?
Keep it short and to the point. 0.55. What is the ratio of the Amount(current US$) of Sub-Saharan Africa (developing only) in 2003 to that in 2004?
Give a very brief answer. 0.75. What is the ratio of the Amount(current US$) in Central African Republic in 2003 to that in 2004?
Offer a very short reply. 0.73. What is the ratio of the Amount(current US$) in Thailand in 2003 to that in 2004?
Provide a short and direct response. 0.8. What is the ratio of the Amount(current US$) of Sub-Saharan Africa (developing only) in 2003 to that in 2005?
Offer a terse response. 0.62. What is the ratio of the Amount(current US$) of Central African Republic in 2003 to that in 2005?
Provide a short and direct response. 0.66. What is the ratio of the Amount(current US$) in Thailand in 2003 to that in 2005?
Your answer should be compact. 0.64. What is the ratio of the Amount(current US$) of Sub-Saharan Africa (developing only) in 2004 to that in 2005?
Offer a very short reply. 0.83. What is the ratio of the Amount(current US$) of Central African Republic in 2004 to that in 2005?
Provide a short and direct response. 0.9. What is the ratio of the Amount(current US$) in Thailand in 2004 to that in 2005?
Provide a short and direct response. 0.8. What is the difference between the highest and the second highest Amount(current US$) of Sub-Saharan Africa (developing only)?
Provide a short and direct response. 2.83e+1. What is the difference between the highest and the second highest Amount(current US$) of Central African Republic?
Offer a very short reply. 2.32e+07. What is the difference between the highest and the second highest Amount(current US$) of Thailand?
Provide a short and direct response. 2.37e+1. What is the difference between the highest and the lowest Amount(current US$) of Sub-Saharan Africa (developing only)?
Your answer should be very brief. 9.51e+1. What is the difference between the highest and the lowest Amount(current US$) of Central African Republic?
Your response must be concise. 1.05e+08. What is the difference between the highest and the lowest Amount(current US$) of Thailand?
Keep it short and to the point. 7.44e+1. 